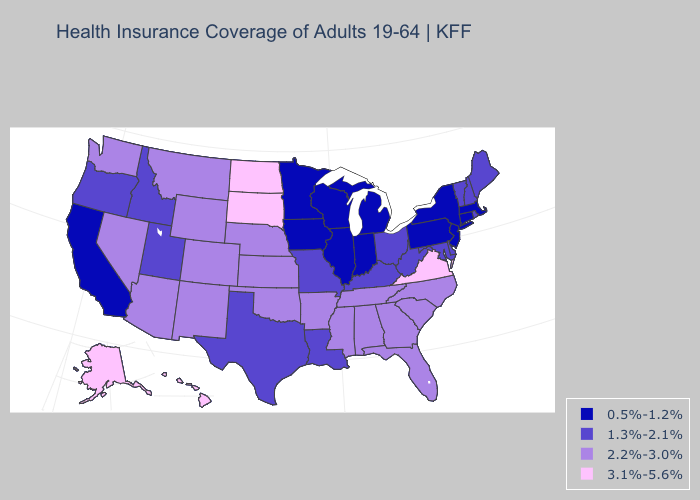Name the states that have a value in the range 0.5%-1.2%?
Concise answer only. California, Connecticut, Illinois, Indiana, Iowa, Massachusetts, Michigan, Minnesota, New Jersey, New York, Pennsylvania, Wisconsin. Which states have the lowest value in the USA?
Write a very short answer. California, Connecticut, Illinois, Indiana, Iowa, Massachusetts, Michigan, Minnesota, New Jersey, New York, Pennsylvania, Wisconsin. Does Louisiana have the same value as Washington?
Answer briefly. No. What is the value of Tennessee?
Short answer required. 2.2%-3.0%. What is the value of Indiana?
Short answer required. 0.5%-1.2%. What is the value of Delaware?
Be succinct. 1.3%-2.1%. Does North Dakota have a higher value than Virginia?
Quick response, please. No. Name the states that have a value in the range 0.5%-1.2%?
Write a very short answer. California, Connecticut, Illinois, Indiana, Iowa, Massachusetts, Michigan, Minnesota, New Jersey, New York, Pennsylvania, Wisconsin. Is the legend a continuous bar?
Quick response, please. No. Does Virginia have the highest value in the South?
Be succinct. Yes. Does Pennsylvania have the lowest value in the USA?
Be succinct. Yes. Does Maryland have the highest value in the USA?
Give a very brief answer. No. Which states have the lowest value in the USA?
Quick response, please. California, Connecticut, Illinois, Indiana, Iowa, Massachusetts, Michigan, Minnesota, New Jersey, New York, Pennsylvania, Wisconsin. Name the states that have a value in the range 2.2%-3.0%?
Quick response, please. Alabama, Arizona, Arkansas, Colorado, Florida, Georgia, Kansas, Mississippi, Montana, Nebraska, Nevada, New Mexico, North Carolina, Oklahoma, South Carolina, Tennessee, Washington, Wyoming. Name the states that have a value in the range 1.3%-2.1%?
Be succinct. Delaware, Idaho, Kentucky, Louisiana, Maine, Maryland, Missouri, New Hampshire, Ohio, Oregon, Rhode Island, Texas, Utah, Vermont, West Virginia. 